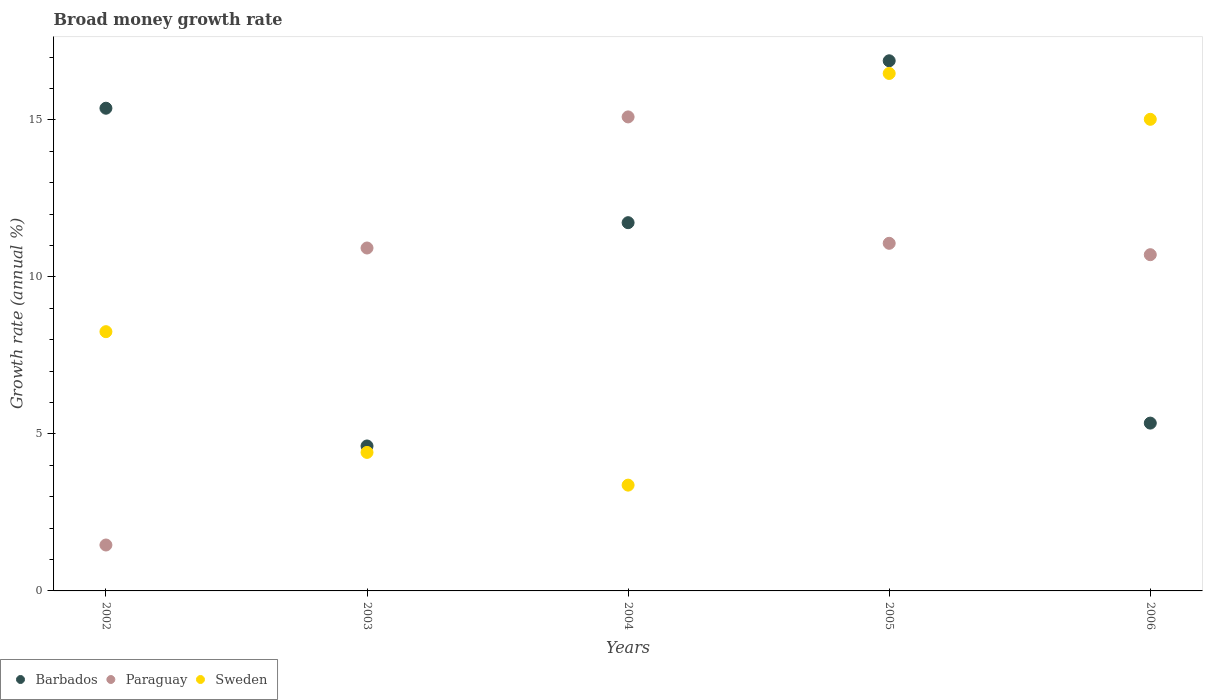How many different coloured dotlines are there?
Ensure brevity in your answer.  3. What is the growth rate in Paraguay in 2006?
Offer a terse response. 10.71. Across all years, what is the maximum growth rate in Barbados?
Provide a short and direct response. 16.89. Across all years, what is the minimum growth rate in Sweden?
Provide a succinct answer. 3.37. What is the total growth rate in Barbados in the graph?
Your answer should be very brief. 53.95. What is the difference between the growth rate in Barbados in 2004 and that in 2005?
Make the answer very short. -5.16. What is the difference between the growth rate in Paraguay in 2003 and the growth rate in Sweden in 2005?
Ensure brevity in your answer.  -5.56. What is the average growth rate in Barbados per year?
Give a very brief answer. 10.79. In the year 2003, what is the difference between the growth rate in Paraguay and growth rate in Barbados?
Keep it short and to the point. 6.31. What is the ratio of the growth rate in Paraguay in 2002 to that in 2003?
Make the answer very short. 0.13. Is the growth rate in Barbados in 2005 less than that in 2006?
Your answer should be very brief. No. What is the difference between the highest and the second highest growth rate in Sweden?
Keep it short and to the point. 1.46. What is the difference between the highest and the lowest growth rate in Barbados?
Offer a terse response. 12.27. In how many years, is the growth rate in Barbados greater than the average growth rate in Barbados taken over all years?
Provide a short and direct response. 3. Is the sum of the growth rate in Barbados in 2003 and 2004 greater than the maximum growth rate in Sweden across all years?
Your answer should be compact. No. Is the growth rate in Barbados strictly greater than the growth rate in Sweden over the years?
Ensure brevity in your answer.  No. Is the growth rate in Paraguay strictly less than the growth rate in Sweden over the years?
Provide a short and direct response. No. How many dotlines are there?
Ensure brevity in your answer.  3. What is the difference between two consecutive major ticks on the Y-axis?
Offer a very short reply. 5. Are the values on the major ticks of Y-axis written in scientific E-notation?
Your answer should be compact. No. Does the graph contain any zero values?
Keep it short and to the point. No. Where does the legend appear in the graph?
Ensure brevity in your answer.  Bottom left. What is the title of the graph?
Provide a succinct answer. Broad money growth rate. Does "Jamaica" appear as one of the legend labels in the graph?
Your answer should be very brief. No. What is the label or title of the X-axis?
Offer a terse response. Years. What is the label or title of the Y-axis?
Provide a short and direct response. Growth rate (annual %). What is the Growth rate (annual %) of Barbados in 2002?
Make the answer very short. 15.37. What is the Growth rate (annual %) of Paraguay in 2002?
Keep it short and to the point. 1.46. What is the Growth rate (annual %) in Sweden in 2002?
Provide a short and direct response. 8.26. What is the Growth rate (annual %) in Barbados in 2003?
Ensure brevity in your answer.  4.62. What is the Growth rate (annual %) in Paraguay in 2003?
Keep it short and to the point. 10.92. What is the Growth rate (annual %) of Sweden in 2003?
Offer a terse response. 4.41. What is the Growth rate (annual %) of Barbados in 2004?
Your answer should be compact. 11.73. What is the Growth rate (annual %) in Paraguay in 2004?
Make the answer very short. 15.1. What is the Growth rate (annual %) of Sweden in 2004?
Provide a succinct answer. 3.37. What is the Growth rate (annual %) of Barbados in 2005?
Your answer should be compact. 16.89. What is the Growth rate (annual %) in Paraguay in 2005?
Offer a terse response. 11.07. What is the Growth rate (annual %) in Sweden in 2005?
Offer a very short reply. 16.48. What is the Growth rate (annual %) in Barbados in 2006?
Make the answer very short. 5.35. What is the Growth rate (annual %) in Paraguay in 2006?
Offer a very short reply. 10.71. What is the Growth rate (annual %) of Sweden in 2006?
Give a very brief answer. 15.02. Across all years, what is the maximum Growth rate (annual %) of Barbados?
Provide a short and direct response. 16.89. Across all years, what is the maximum Growth rate (annual %) of Paraguay?
Provide a succinct answer. 15.1. Across all years, what is the maximum Growth rate (annual %) of Sweden?
Your response must be concise. 16.48. Across all years, what is the minimum Growth rate (annual %) of Barbados?
Provide a succinct answer. 4.62. Across all years, what is the minimum Growth rate (annual %) in Paraguay?
Your response must be concise. 1.46. Across all years, what is the minimum Growth rate (annual %) in Sweden?
Offer a terse response. 3.37. What is the total Growth rate (annual %) of Barbados in the graph?
Provide a succinct answer. 53.95. What is the total Growth rate (annual %) in Paraguay in the graph?
Offer a very short reply. 49.26. What is the total Growth rate (annual %) in Sweden in the graph?
Make the answer very short. 47.54. What is the difference between the Growth rate (annual %) in Barbados in 2002 and that in 2003?
Make the answer very short. 10.76. What is the difference between the Growth rate (annual %) of Paraguay in 2002 and that in 2003?
Give a very brief answer. -9.46. What is the difference between the Growth rate (annual %) in Sweden in 2002 and that in 2003?
Your response must be concise. 3.85. What is the difference between the Growth rate (annual %) in Barbados in 2002 and that in 2004?
Make the answer very short. 3.65. What is the difference between the Growth rate (annual %) of Paraguay in 2002 and that in 2004?
Your response must be concise. -13.64. What is the difference between the Growth rate (annual %) in Sweden in 2002 and that in 2004?
Provide a short and direct response. 4.89. What is the difference between the Growth rate (annual %) of Barbados in 2002 and that in 2005?
Provide a short and direct response. -1.51. What is the difference between the Growth rate (annual %) in Paraguay in 2002 and that in 2005?
Offer a terse response. -9.61. What is the difference between the Growth rate (annual %) of Sweden in 2002 and that in 2005?
Ensure brevity in your answer.  -8.22. What is the difference between the Growth rate (annual %) of Barbados in 2002 and that in 2006?
Keep it short and to the point. 10.03. What is the difference between the Growth rate (annual %) in Paraguay in 2002 and that in 2006?
Give a very brief answer. -9.25. What is the difference between the Growth rate (annual %) in Sweden in 2002 and that in 2006?
Give a very brief answer. -6.76. What is the difference between the Growth rate (annual %) in Barbados in 2003 and that in 2004?
Offer a very short reply. -7.11. What is the difference between the Growth rate (annual %) of Paraguay in 2003 and that in 2004?
Provide a succinct answer. -4.18. What is the difference between the Growth rate (annual %) in Sweden in 2003 and that in 2004?
Make the answer very short. 1.04. What is the difference between the Growth rate (annual %) of Barbados in 2003 and that in 2005?
Offer a terse response. -12.27. What is the difference between the Growth rate (annual %) in Paraguay in 2003 and that in 2005?
Ensure brevity in your answer.  -0.15. What is the difference between the Growth rate (annual %) in Sweden in 2003 and that in 2005?
Offer a very short reply. -12.07. What is the difference between the Growth rate (annual %) in Barbados in 2003 and that in 2006?
Offer a very short reply. -0.73. What is the difference between the Growth rate (annual %) in Paraguay in 2003 and that in 2006?
Provide a short and direct response. 0.21. What is the difference between the Growth rate (annual %) in Sweden in 2003 and that in 2006?
Make the answer very short. -10.61. What is the difference between the Growth rate (annual %) in Barbados in 2004 and that in 2005?
Your answer should be very brief. -5.16. What is the difference between the Growth rate (annual %) in Paraguay in 2004 and that in 2005?
Provide a succinct answer. 4.03. What is the difference between the Growth rate (annual %) of Sweden in 2004 and that in 2005?
Your response must be concise. -13.11. What is the difference between the Growth rate (annual %) in Barbados in 2004 and that in 2006?
Give a very brief answer. 6.38. What is the difference between the Growth rate (annual %) of Paraguay in 2004 and that in 2006?
Your response must be concise. 4.39. What is the difference between the Growth rate (annual %) of Sweden in 2004 and that in 2006?
Give a very brief answer. -11.65. What is the difference between the Growth rate (annual %) in Barbados in 2005 and that in 2006?
Give a very brief answer. 11.54. What is the difference between the Growth rate (annual %) of Paraguay in 2005 and that in 2006?
Make the answer very short. 0.36. What is the difference between the Growth rate (annual %) of Sweden in 2005 and that in 2006?
Give a very brief answer. 1.46. What is the difference between the Growth rate (annual %) of Barbados in 2002 and the Growth rate (annual %) of Paraguay in 2003?
Offer a very short reply. 4.45. What is the difference between the Growth rate (annual %) of Barbados in 2002 and the Growth rate (annual %) of Sweden in 2003?
Provide a short and direct response. 10.96. What is the difference between the Growth rate (annual %) in Paraguay in 2002 and the Growth rate (annual %) in Sweden in 2003?
Your answer should be compact. -2.95. What is the difference between the Growth rate (annual %) of Barbados in 2002 and the Growth rate (annual %) of Paraguay in 2004?
Give a very brief answer. 0.28. What is the difference between the Growth rate (annual %) of Barbados in 2002 and the Growth rate (annual %) of Sweden in 2004?
Your response must be concise. 12.01. What is the difference between the Growth rate (annual %) of Paraguay in 2002 and the Growth rate (annual %) of Sweden in 2004?
Keep it short and to the point. -1.91. What is the difference between the Growth rate (annual %) of Barbados in 2002 and the Growth rate (annual %) of Paraguay in 2005?
Offer a terse response. 4.3. What is the difference between the Growth rate (annual %) of Barbados in 2002 and the Growth rate (annual %) of Sweden in 2005?
Provide a short and direct response. -1.11. What is the difference between the Growth rate (annual %) in Paraguay in 2002 and the Growth rate (annual %) in Sweden in 2005?
Provide a short and direct response. -15.02. What is the difference between the Growth rate (annual %) in Barbados in 2002 and the Growth rate (annual %) in Paraguay in 2006?
Keep it short and to the point. 4.67. What is the difference between the Growth rate (annual %) of Barbados in 2002 and the Growth rate (annual %) of Sweden in 2006?
Make the answer very short. 0.35. What is the difference between the Growth rate (annual %) in Paraguay in 2002 and the Growth rate (annual %) in Sweden in 2006?
Ensure brevity in your answer.  -13.56. What is the difference between the Growth rate (annual %) in Barbados in 2003 and the Growth rate (annual %) in Paraguay in 2004?
Your response must be concise. -10.48. What is the difference between the Growth rate (annual %) in Barbados in 2003 and the Growth rate (annual %) in Sweden in 2004?
Your response must be concise. 1.25. What is the difference between the Growth rate (annual %) of Paraguay in 2003 and the Growth rate (annual %) of Sweden in 2004?
Provide a succinct answer. 7.55. What is the difference between the Growth rate (annual %) of Barbados in 2003 and the Growth rate (annual %) of Paraguay in 2005?
Provide a short and direct response. -6.46. What is the difference between the Growth rate (annual %) of Barbados in 2003 and the Growth rate (annual %) of Sweden in 2005?
Make the answer very short. -11.87. What is the difference between the Growth rate (annual %) of Paraguay in 2003 and the Growth rate (annual %) of Sweden in 2005?
Provide a succinct answer. -5.56. What is the difference between the Growth rate (annual %) in Barbados in 2003 and the Growth rate (annual %) in Paraguay in 2006?
Your answer should be compact. -6.09. What is the difference between the Growth rate (annual %) of Barbados in 2003 and the Growth rate (annual %) of Sweden in 2006?
Provide a short and direct response. -10.4. What is the difference between the Growth rate (annual %) in Paraguay in 2003 and the Growth rate (annual %) in Sweden in 2006?
Your answer should be compact. -4.1. What is the difference between the Growth rate (annual %) of Barbados in 2004 and the Growth rate (annual %) of Paraguay in 2005?
Your response must be concise. 0.66. What is the difference between the Growth rate (annual %) of Barbados in 2004 and the Growth rate (annual %) of Sweden in 2005?
Ensure brevity in your answer.  -4.75. What is the difference between the Growth rate (annual %) of Paraguay in 2004 and the Growth rate (annual %) of Sweden in 2005?
Your answer should be compact. -1.38. What is the difference between the Growth rate (annual %) of Barbados in 2004 and the Growth rate (annual %) of Paraguay in 2006?
Offer a very short reply. 1.02. What is the difference between the Growth rate (annual %) of Barbados in 2004 and the Growth rate (annual %) of Sweden in 2006?
Your response must be concise. -3.29. What is the difference between the Growth rate (annual %) in Paraguay in 2004 and the Growth rate (annual %) in Sweden in 2006?
Ensure brevity in your answer.  0.08. What is the difference between the Growth rate (annual %) of Barbados in 2005 and the Growth rate (annual %) of Paraguay in 2006?
Keep it short and to the point. 6.18. What is the difference between the Growth rate (annual %) of Barbados in 2005 and the Growth rate (annual %) of Sweden in 2006?
Give a very brief answer. 1.86. What is the difference between the Growth rate (annual %) in Paraguay in 2005 and the Growth rate (annual %) in Sweden in 2006?
Keep it short and to the point. -3.95. What is the average Growth rate (annual %) of Barbados per year?
Give a very brief answer. 10.79. What is the average Growth rate (annual %) of Paraguay per year?
Provide a short and direct response. 9.85. What is the average Growth rate (annual %) of Sweden per year?
Keep it short and to the point. 9.51. In the year 2002, what is the difference between the Growth rate (annual %) in Barbados and Growth rate (annual %) in Paraguay?
Give a very brief answer. 13.91. In the year 2002, what is the difference between the Growth rate (annual %) of Barbados and Growth rate (annual %) of Sweden?
Give a very brief answer. 7.12. In the year 2002, what is the difference between the Growth rate (annual %) in Paraguay and Growth rate (annual %) in Sweden?
Your answer should be compact. -6.8. In the year 2003, what is the difference between the Growth rate (annual %) of Barbados and Growth rate (annual %) of Paraguay?
Your answer should be compact. -6.31. In the year 2003, what is the difference between the Growth rate (annual %) in Barbados and Growth rate (annual %) in Sweden?
Keep it short and to the point. 0.2. In the year 2003, what is the difference between the Growth rate (annual %) of Paraguay and Growth rate (annual %) of Sweden?
Ensure brevity in your answer.  6.51. In the year 2004, what is the difference between the Growth rate (annual %) of Barbados and Growth rate (annual %) of Paraguay?
Your response must be concise. -3.37. In the year 2004, what is the difference between the Growth rate (annual %) in Barbados and Growth rate (annual %) in Sweden?
Your answer should be very brief. 8.36. In the year 2004, what is the difference between the Growth rate (annual %) of Paraguay and Growth rate (annual %) of Sweden?
Keep it short and to the point. 11.73. In the year 2005, what is the difference between the Growth rate (annual %) of Barbados and Growth rate (annual %) of Paraguay?
Ensure brevity in your answer.  5.81. In the year 2005, what is the difference between the Growth rate (annual %) of Barbados and Growth rate (annual %) of Sweden?
Make the answer very short. 0.4. In the year 2005, what is the difference between the Growth rate (annual %) of Paraguay and Growth rate (annual %) of Sweden?
Your answer should be very brief. -5.41. In the year 2006, what is the difference between the Growth rate (annual %) in Barbados and Growth rate (annual %) in Paraguay?
Provide a succinct answer. -5.36. In the year 2006, what is the difference between the Growth rate (annual %) in Barbados and Growth rate (annual %) in Sweden?
Your answer should be very brief. -9.68. In the year 2006, what is the difference between the Growth rate (annual %) of Paraguay and Growth rate (annual %) of Sweden?
Provide a short and direct response. -4.31. What is the ratio of the Growth rate (annual %) of Barbados in 2002 to that in 2003?
Your answer should be very brief. 3.33. What is the ratio of the Growth rate (annual %) in Paraguay in 2002 to that in 2003?
Make the answer very short. 0.13. What is the ratio of the Growth rate (annual %) in Sweden in 2002 to that in 2003?
Provide a succinct answer. 1.87. What is the ratio of the Growth rate (annual %) in Barbados in 2002 to that in 2004?
Provide a short and direct response. 1.31. What is the ratio of the Growth rate (annual %) in Paraguay in 2002 to that in 2004?
Give a very brief answer. 0.1. What is the ratio of the Growth rate (annual %) in Sweden in 2002 to that in 2004?
Offer a very short reply. 2.45. What is the ratio of the Growth rate (annual %) in Barbados in 2002 to that in 2005?
Provide a succinct answer. 0.91. What is the ratio of the Growth rate (annual %) of Paraguay in 2002 to that in 2005?
Provide a succinct answer. 0.13. What is the ratio of the Growth rate (annual %) of Sweden in 2002 to that in 2005?
Ensure brevity in your answer.  0.5. What is the ratio of the Growth rate (annual %) of Barbados in 2002 to that in 2006?
Provide a succinct answer. 2.88. What is the ratio of the Growth rate (annual %) in Paraguay in 2002 to that in 2006?
Your answer should be compact. 0.14. What is the ratio of the Growth rate (annual %) of Sweden in 2002 to that in 2006?
Make the answer very short. 0.55. What is the ratio of the Growth rate (annual %) of Barbados in 2003 to that in 2004?
Make the answer very short. 0.39. What is the ratio of the Growth rate (annual %) in Paraguay in 2003 to that in 2004?
Offer a very short reply. 0.72. What is the ratio of the Growth rate (annual %) in Sweden in 2003 to that in 2004?
Your answer should be very brief. 1.31. What is the ratio of the Growth rate (annual %) of Barbados in 2003 to that in 2005?
Provide a succinct answer. 0.27. What is the ratio of the Growth rate (annual %) in Paraguay in 2003 to that in 2005?
Make the answer very short. 0.99. What is the ratio of the Growth rate (annual %) in Sweden in 2003 to that in 2005?
Offer a terse response. 0.27. What is the ratio of the Growth rate (annual %) of Barbados in 2003 to that in 2006?
Your response must be concise. 0.86. What is the ratio of the Growth rate (annual %) in Paraguay in 2003 to that in 2006?
Make the answer very short. 1.02. What is the ratio of the Growth rate (annual %) of Sweden in 2003 to that in 2006?
Offer a terse response. 0.29. What is the ratio of the Growth rate (annual %) of Barbados in 2004 to that in 2005?
Your response must be concise. 0.69. What is the ratio of the Growth rate (annual %) in Paraguay in 2004 to that in 2005?
Make the answer very short. 1.36. What is the ratio of the Growth rate (annual %) of Sweden in 2004 to that in 2005?
Offer a very short reply. 0.2. What is the ratio of the Growth rate (annual %) in Barbados in 2004 to that in 2006?
Provide a succinct answer. 2.19. What is the ratio of the Growth rate (annual %) of Paraguay in 2004 to that in 2006?
Keep it short and to the point. 1.41. What is the ratio of the Growth rate (annual %) in Sweden in 2004 to that in 2006?
Your response must be concise. 0.22. What is the ratio of the Growth rate (annual %) of Barbados in 2005 to that in 2006?
Offer a very short reply. 3.16. What is the ratio of the Growth rate (annual %) of Paraguay in 2005 to that in 2006?
Provide a short and direct response. 1.03. What is the ratio of the Growth rate (annual %) in Sweden in 2005 to that in 2006?
Your response must be concise. 1.1. What is the difference between the highest and the second highest Growth rate (annual %) in Barbados?
Your response must be concise. 1.51. What is the difference between the highest and the second highest Growth rate (annual %) in Paraguay?
Offer a very short reply. 4.03. What is the difference between the highest and the second highest Growth rate (annual %) in Sweden?
Your response must be concise. 1.46. What is the difference between the highest and the lowest Growth rate (annual %) of Barbados?
Make the answer very short. 12.27. What is the difference between the highest and the lowest Growth rate (annual %) of Paraguay?
Offer a terse response. 13.64. What is the difference between the highest and the lowest Growth rate (annual %) of Sweden?
Your answer should be compact. 13.11. 